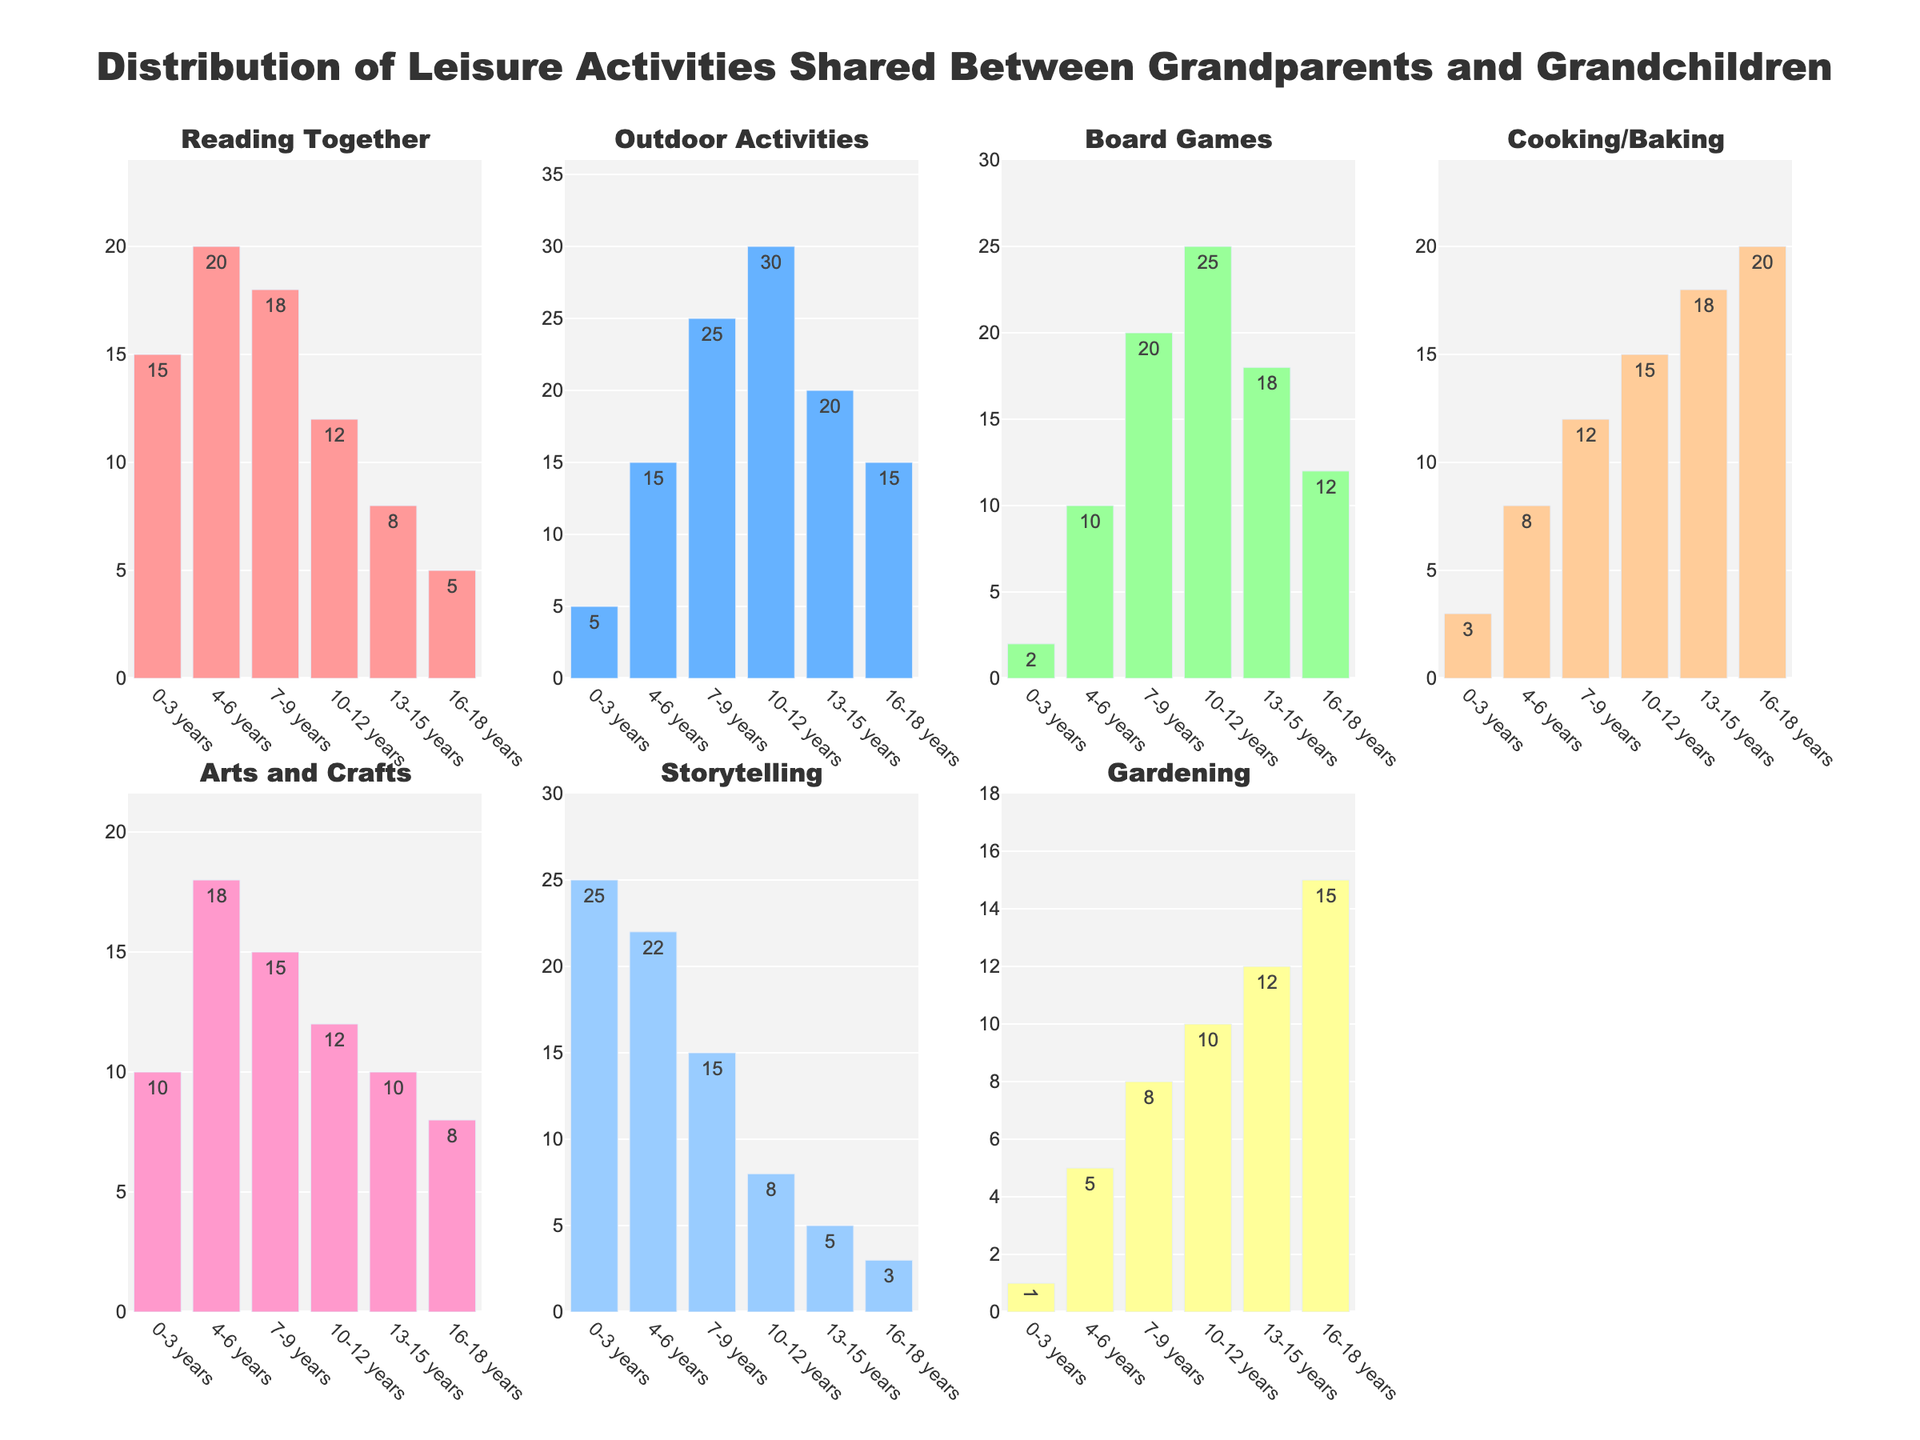What's the title of the overall figure? The title of the overall figure is displayed at the top and reads "Distribution of Leisure Activities Shared Between Grandparents and Grandchildren".
Answer: Distribution of Leisure Activities Shared Between Grandparents and Grandchildren Which age group has the highest number of outdoor activities? By looking at the subplot for outdoor activities, you can see the longest bar indicates the number of activities for the 10-12 years age group.
Answer: 10-12 years What's the trend in gardening activities as the age groups increase? By observing the gardening subplot, one can see the number of gardening activities generally increases from the 0-3 years age group and peaks at the 16-18 years age group.
Answer: Increases How many total storytelling activities are shared across all age groups? Adding up the values from the storytelling subplot (25 + 22 + 15 + 8 + 5 + 3) gives a total of 78.
Answer: 78 Which activity has the most significant drop in participation as the age group gets older? Comparing the plots, storytelling shows the most significant reduction from 25 activities (0-3 years) to 3 activities (16-18 years).
Answer: Storytelling How does the number of reading together activities compare between the age groups of 4-6 years and 13-15 years? The subplot for reading together shows 20 activities for 4-6 years and 8 activities for 13-15 years. The number is higher in the younger age group.
Answer: 4-6 years > 13-15 years Which age group engages the most in cooking/baking activities? The tallest bar in the cooking/baking subplot corresponds to the 16-18 years age group.
Answer: 16-18 years Is there a consistent trend for arts and crafts activities across age groups? Observing the subplot for arts and crafts, the numbers fluctuate but generally decrease as the age groups progress.
Answer: Decreases What is the combined total of board games activities for the 7-9 years and 10-12 years age groups? Summing up the values from the board games subplot for 7-9 years (20) and 10-12 years (25) gives a total of 45.
Answer: 45 